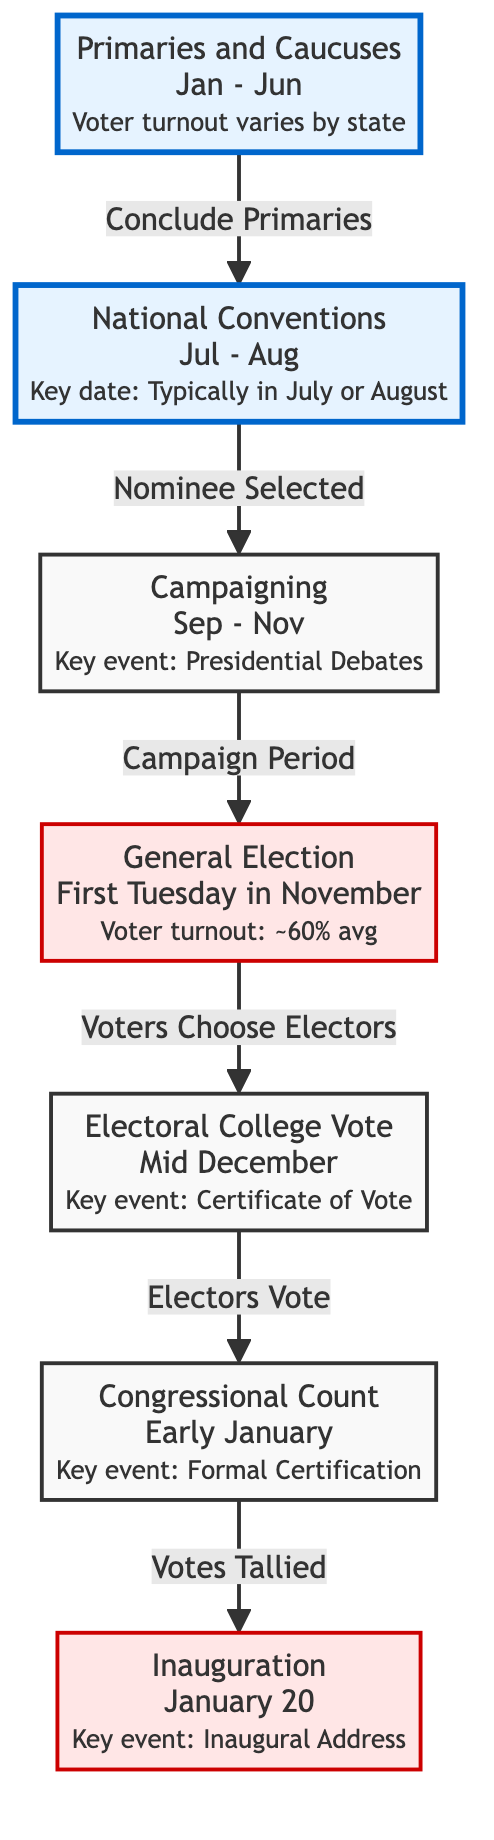What are the key months for the Primaries and Caucuses stage? The diagram indicates that the Primaries and Caucuses take place from January to June. This is directly stated in the node representing this stage.
Answer: Jan - Jun What follows the National Conventions? The diagram shows that the National Conventions are followed by the Campaigning stage. This is indicated by the directional flow from the National Conventions to Campaigning.
Answer: Campaigning What is the average voter turnout for the General Election? The node for the General Election states that the average voter turnout is approximately 60%. This information is explicitly provided in the node details.
Answer: ~60% What is the key event associated with the Electoral College Vote? The diagram specifies that the key event related to the Electoral College Vote is the Certificate of Vote, as mentioned in the node description.
Answer: Certificate of Vote How many main stages are there from Primaries to Inauguration? The flowchart demonstrates a total of six main stages, as inferred by counting the number of unique stages illustrated between Primaries and Inauguration.
Answer: 6 What is the key date for Inauguration? The Inauguration node clearly states that the key date for this event is January 20, which is directly outlined in its description.
Answer: January 20 What connects the General Election and the Electoral College Vote? The arrow connecting these two stages indicates that voters choose electors after the General Election, clearly establishing the relationship between them.
Answer: Voters Choose Electors What signifies the end of the campaigning period? The diagram indicates that the campaigning period concludes with the General Election, as depicted by the directional flow from Campaigning to General Election.
Answer: General Election What major event occurs early in January? As per the Congressional Count node, the major event occurring in early January is the Formal Certification, which is specifically mentioned in the node description.
Answer: Formal Certification 